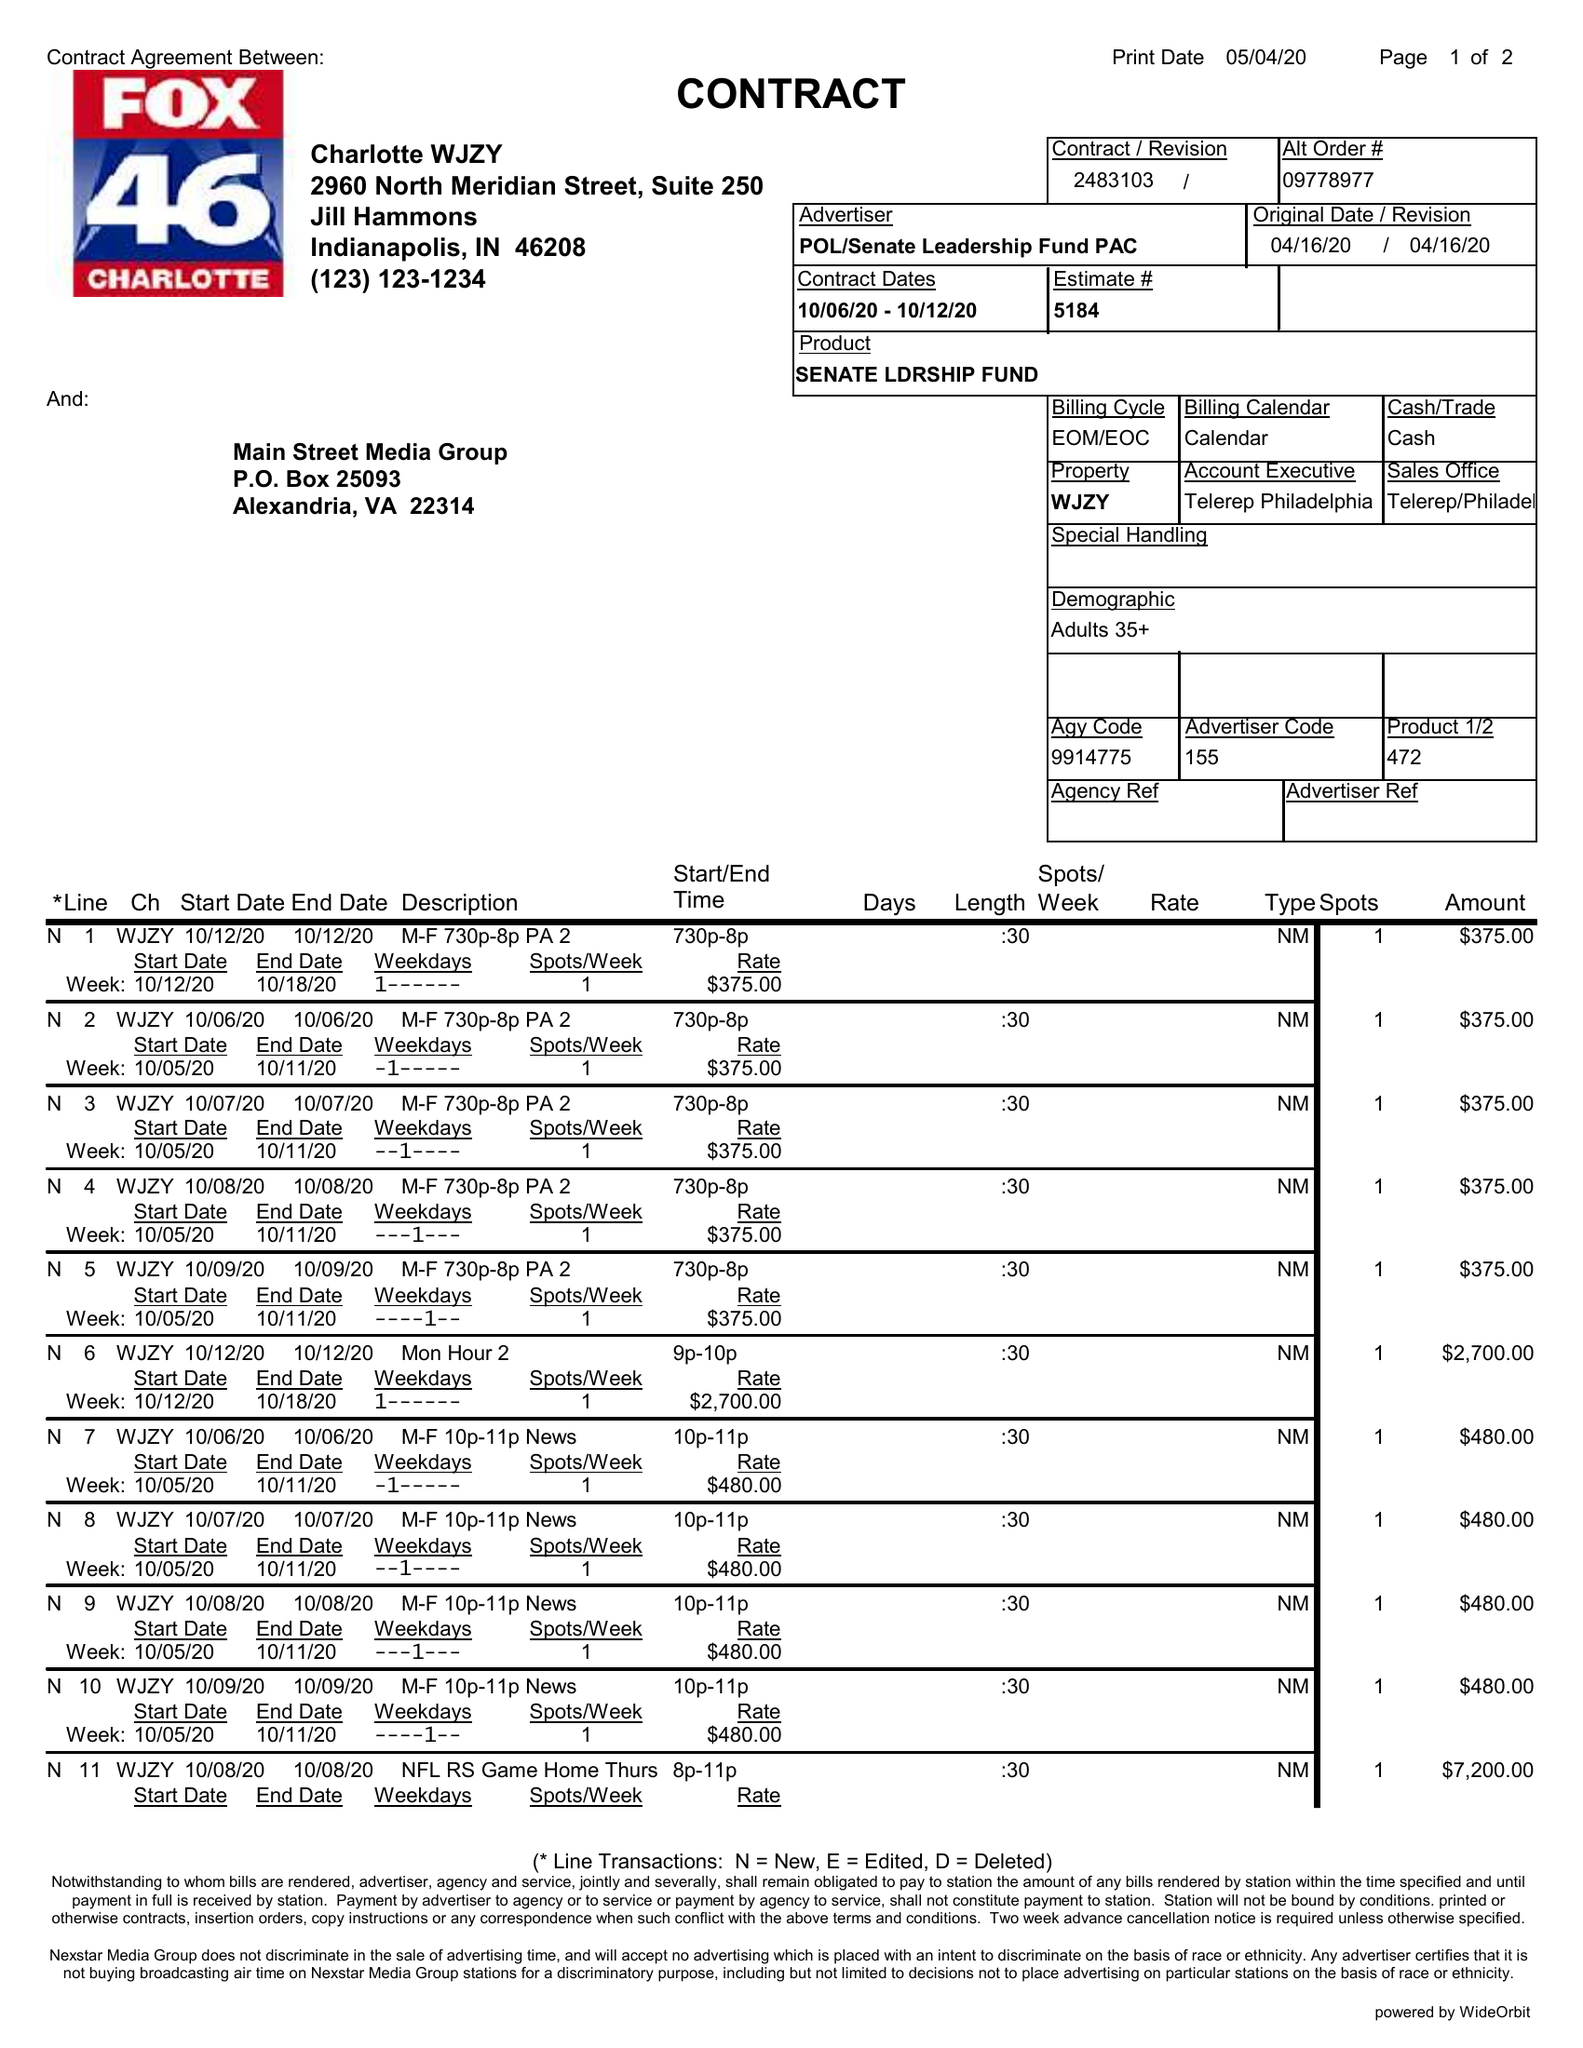What is the value for the gross_amount?
Answer the question using a single word or phrase. 76695.00 